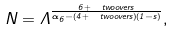<formula> <loc_0><loc_0><loc_500><loc_500>N = \Lambda ^ { \frac { 6 + \ t w o o v e r s } { \alpha _ { 6 } - ( 4 + \ t w o o v e r s ) ( 1 - s ) } } ,</formula> 